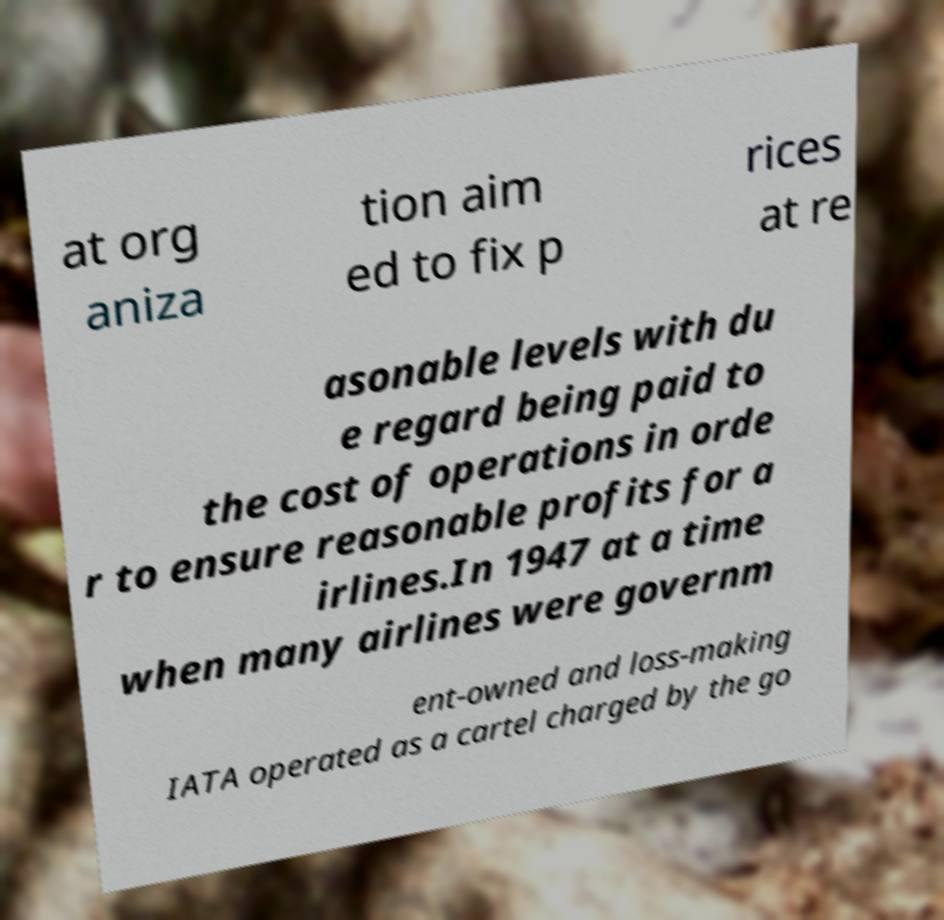Could you extract and type out the text from this image? at org aniza tion aim ed to fix p rices at re asonable levels with du e regard being paid to the cost of operations in orde r to ensure reasonable profits for a irlines.In 1947 at a time when many airlines were governm ent-owned and loss-making IATA operated as a cartel charged by the go 